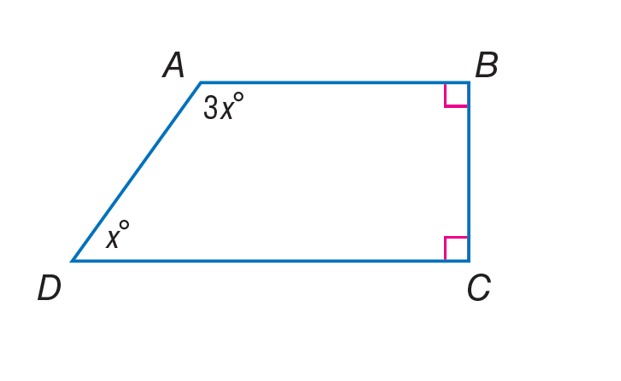Answer the mathemtical geometry problem and directly provide the correct option letter.
Question: Find \angle B of quadrilateral A B C D.
Choices: A: 45 B: 90 C: 135 D: 180 B 